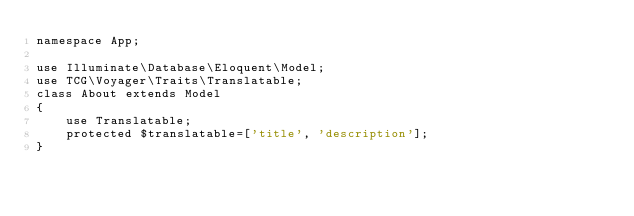Convert code to text. <code><loc_0><loc_0><loc_500><loc_500><_PHP_>namespace App;

use Illuminate\Database\Eloquent\Model;
use TCG\Voyager\Traits\Translatable;
class About extends Model
{
    use Translatable;
    protected $translatable=['title', 'description'];
}</code> 